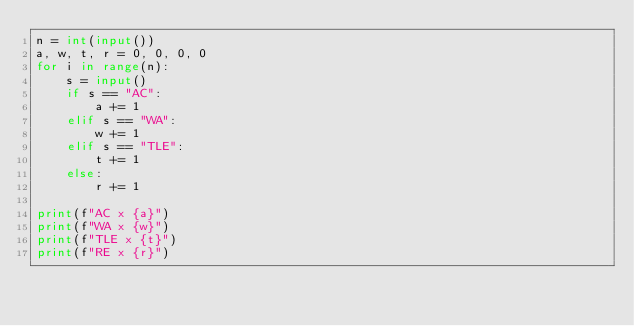<code> <loc_0><loc_0><loc_500><loc_500><_Python_>n = int(input())
a, w, t, r = 0, 0, 0, 0
for i in range(n):
    s = input()
    if s == "AC":
        a += 1
    elif s == "WA":
        w += 1
    elif s == "TLE":
        t += 1
    else:
        r += 1

print(f"AC x {a}")
print(f"WA x {w}")
print(f"TLE x {t}")
print(f"RE x {r}")
</code> 